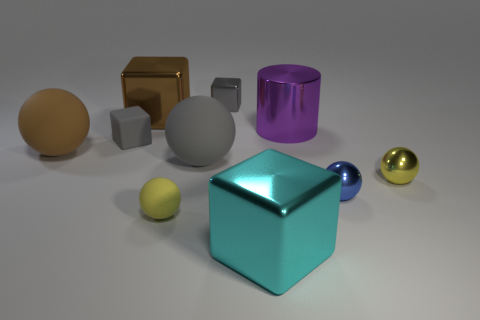Subtract all yellow spheres. How many were subtracted if there are1yellow spheres left? 1 Subtract all gray spheres. How many spheres are left? 4 Subtract all large gray rubber balls. How many balls are left? 4 Subtract all purple blocks. Subtract all yellow balls. How many blocks are left? 4 Subtract all cylinders. How many objects are left? 9 Subtract all large gray balls. Subtract all large metallic cubes. How many objects are left? 7 Add 1 large spheres. How many large spheres are left? 3 Add 8 tiny yellow matte objects. How many tiny yellow matte objects exist? 9 Subtract 0 cyan cylinders. How many objects are left? 10 